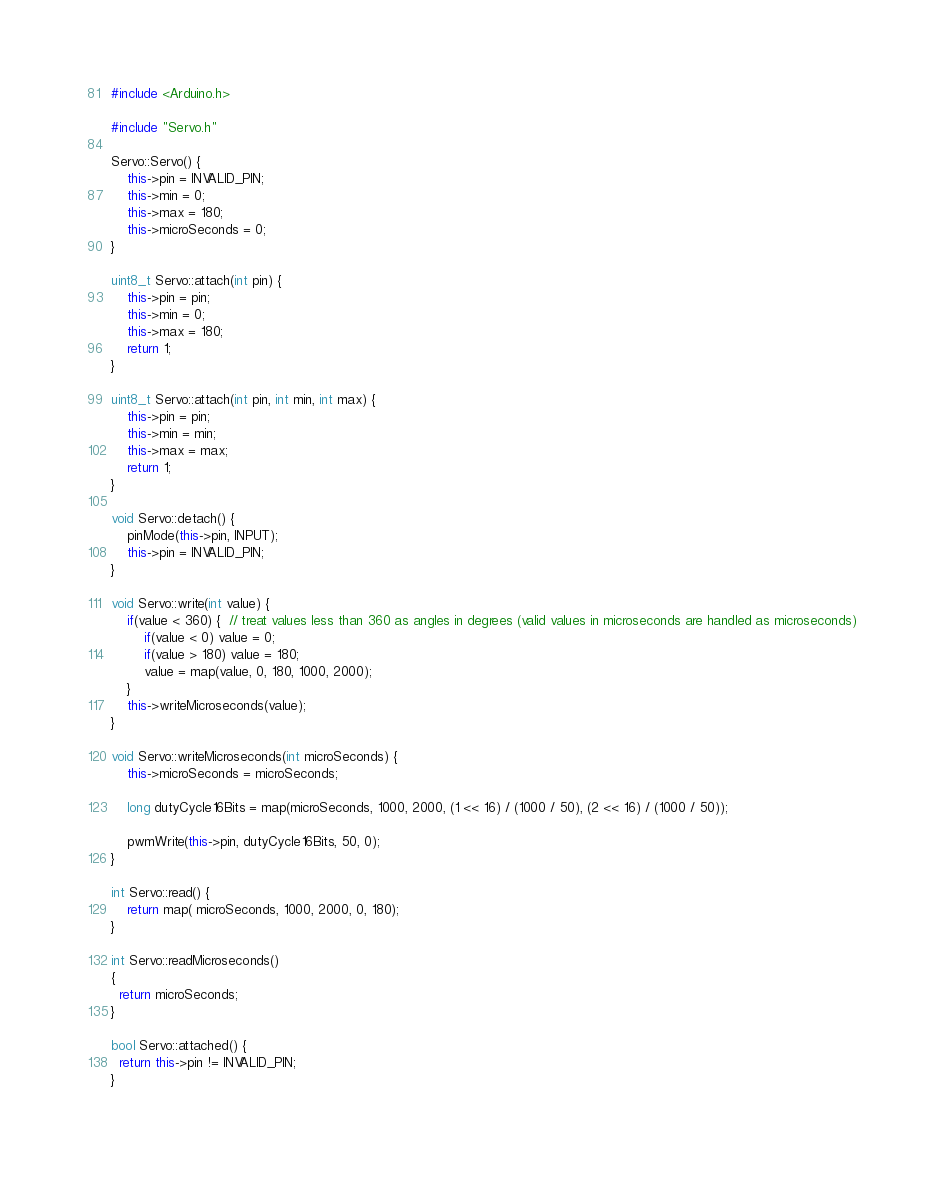Convert code to text. <code><loc_0><loc_0><loc_500><loc_500><_C++_>#include <Arduino.h>

#include "Servo.h"

Servo::Servo() {
    this->pin = INVALID_PIN;
    this->min = 0;
    this->max = 180;
    this->microSeconds = 0;
}

uint8_t Servo::attach(int pin) {
    this->pin = pin;
    this->min = 0;
    this->max = 180;
    return 1;
}

uint8_t Servo::attach(int pin, int min, int max) {
    this->pin = pin;
    this->min = min;
    this->max = max;
    return 1;
}

void Servo::detach() {
    pinMode(this->pin, INPUT);
    this->pin = INVALID_PIN;
}

void Servo::write(int value) {
    if(value < 360) {  // treat values less than 360 as angles in degrees (valid values in microseconds are handled as microseconds)
        if(value < 0) value = 0;
        if(value > 180) value = 180;
        value = map(value, 0, 180, 1000, 2000);
    }
    this->writeMicroseconds(value);
}

void Servo::writeMicroseconds(int microSeconds) {
    this->microSeconds = microSeconds;

    long dutyCycle16Bits = map(microSeconds, 1000, 2000, (1 << 16) / (1000 / 50), (2 << 16) / (1000 / 50));

    pwmWrite(this->pin, dutyCycle16Bits, 50, 0);
}

int Servo::read() {
    return map( microSeconds, 1000, 2000, 0, 180);
}

int Servo::readMicroseconds()
{
  return microSeconds;
}

bool Servo::attached() {
  return this->pin != INVALID_PIN;
}
</code> 